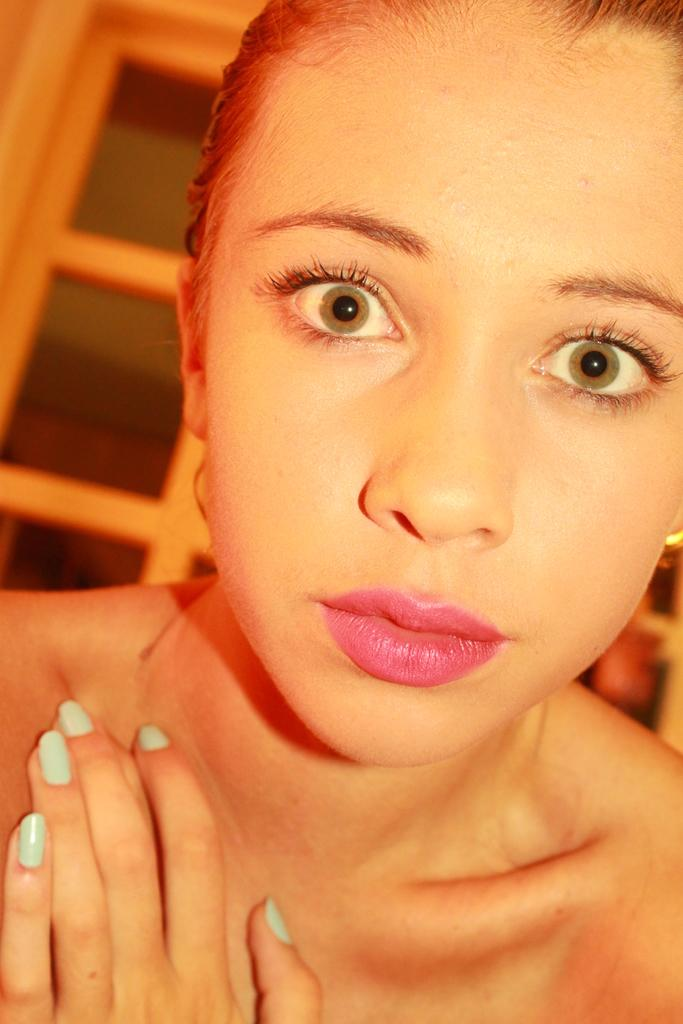Who is the main subject in the image? There is a woman in the image. What is the woman doing in the image? The woman is looking forward. Can you describe the background of the image? The background of the image is blurred. What type of pear can be seen in the background of the image? There is no pear present in the image; the background is blurred. 